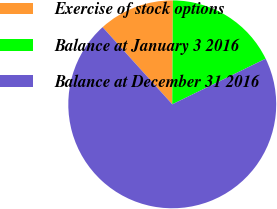<chart> <loc_0><loc_0><loc_500><loc_500><pie_chart><fcel>Exercise of stock options<fcel>Balance at January 3 2016<fcel>Balance at December 31 2016<nl><fcel>11.79%<fcel>17.67%<fcel>70.54%<nl></chart> 